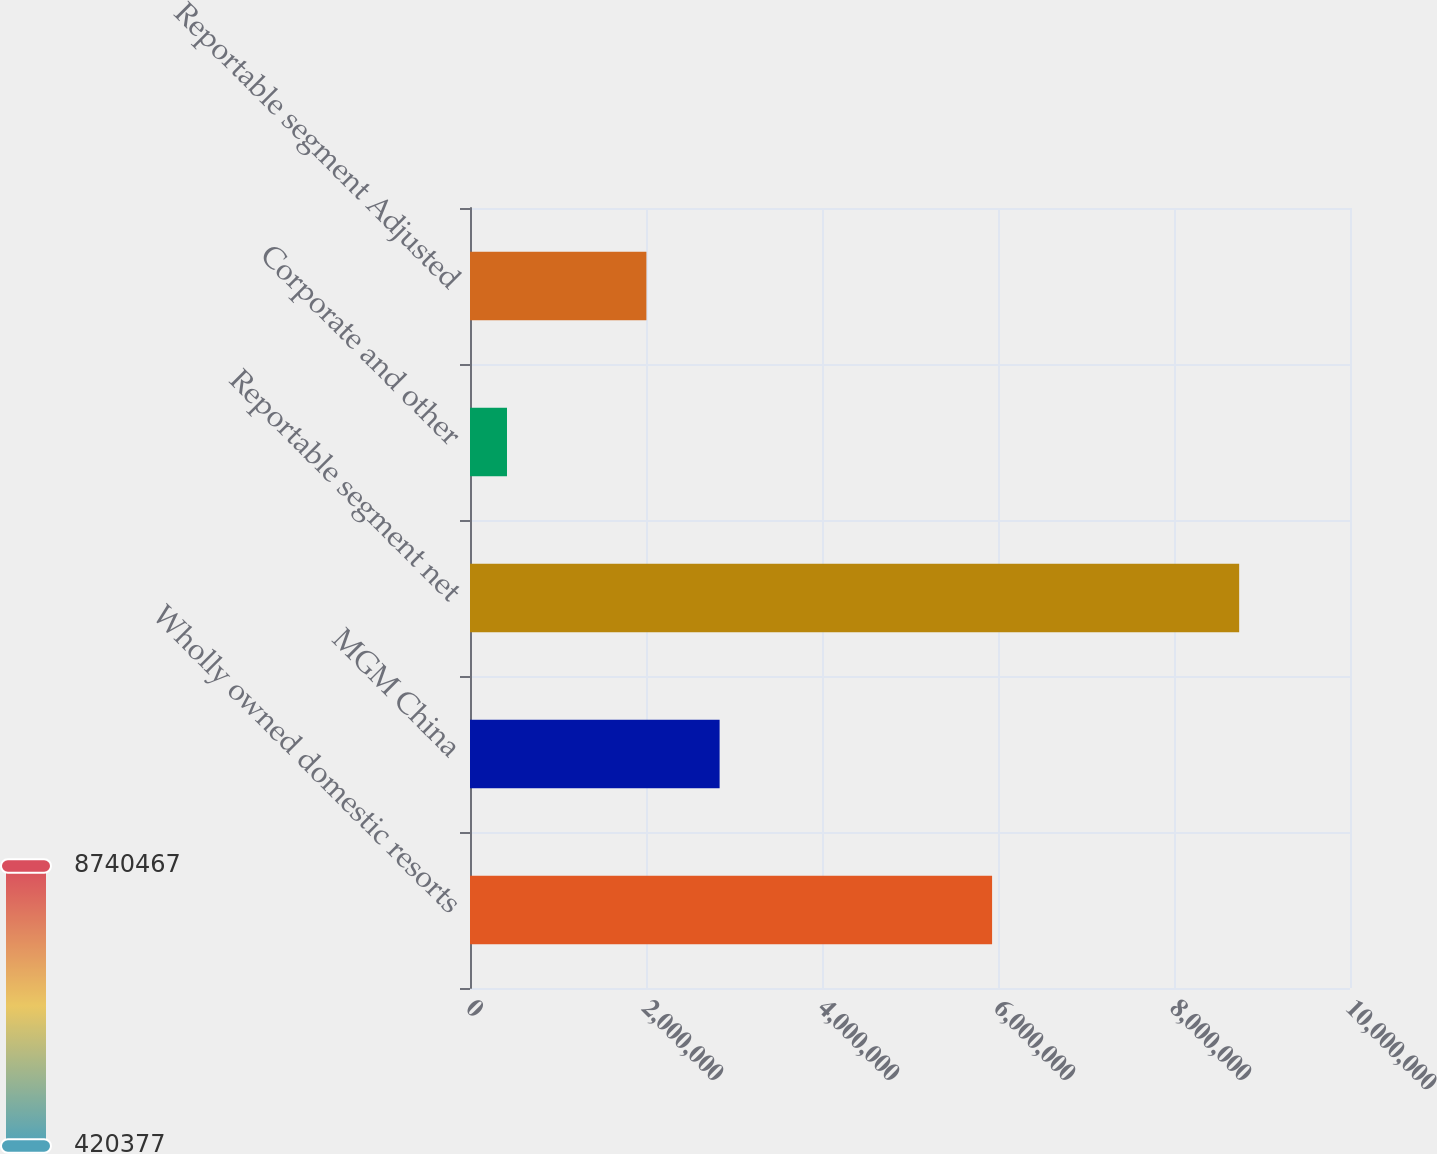<chart> <loc_0><loc_0><loc_500><loc_500><bar_chart><fcel>Wholly owned domestic resorts<fcel>MGM China<fcel>Reportable segment net<fcel>Corporate and other<fcel>Reportable segment Adjusted<nl><fcel>5.93279e+06<fcel>2.83657e+06<fcel>8.74047e+06<fcel>420377<fcel>2.00456e+06<nl></chart> 